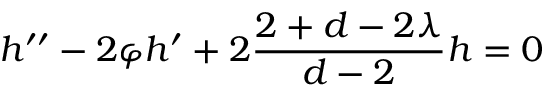Convert formula to latex. <formula><loc_0><loc_0><loc_500><loc_500>h ^ { \prime \prime } - 2 \varphi h ^ { \prime } + 2 \frac { 2 + d - 2 \lambda } { d - 2 } h = 0</formula> 